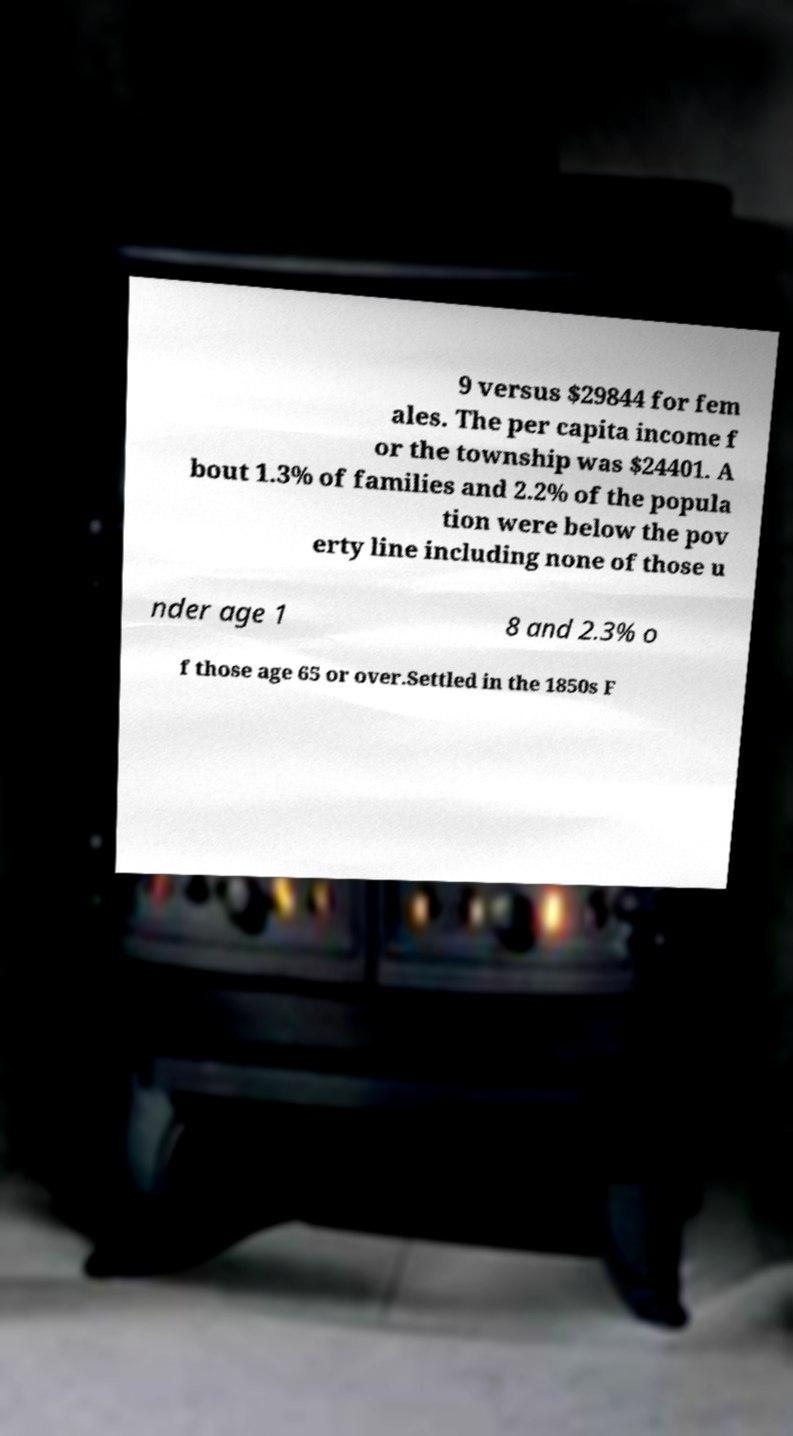There's text embedded in this image that I need extracted. Can you transcribe it verbatim? 9 versus $29844 for fem ales. The per capita income f or the township was $24401. A bout 1.3% of families and 2.2% of the popula tion were below the pov erty line including none of those u nder age 1 8 and 2.3% o f those age 65 or over.Settled in the 1850s F 